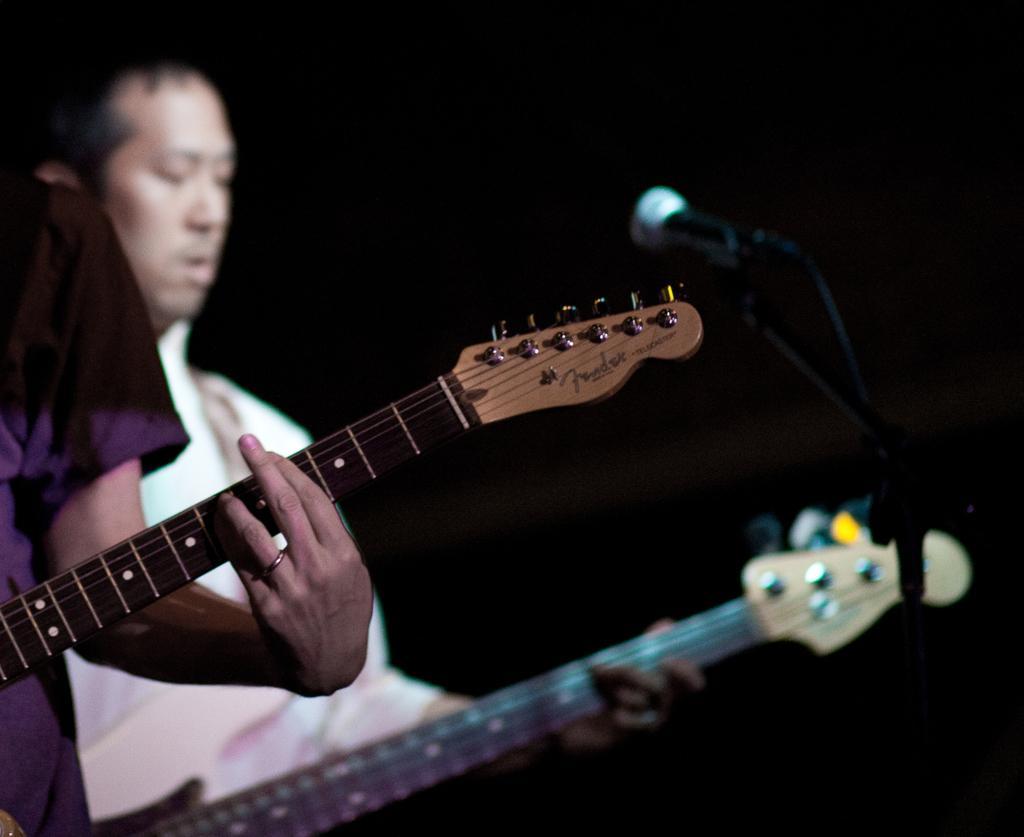Please provide a concise description of this image. In the image we can see there is a person who is standing and holding guitar in their hand and the image is little blurry. 